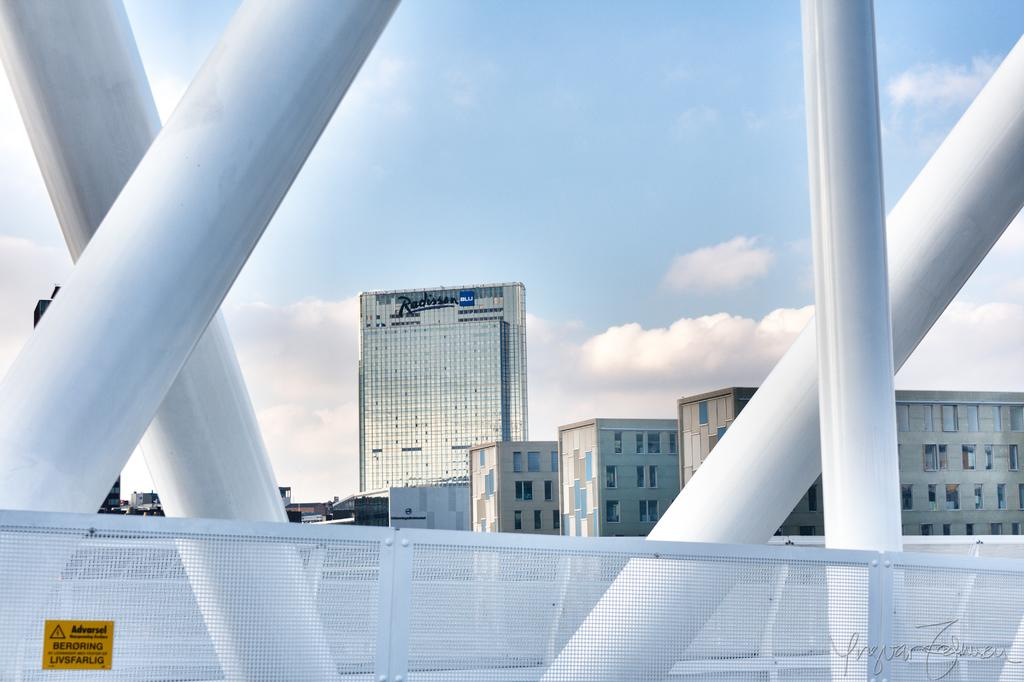<image>
Give a short and clear explanation of the subsequent image. A picture taken from a bridge with a Radisson BLU hotel in the background. 